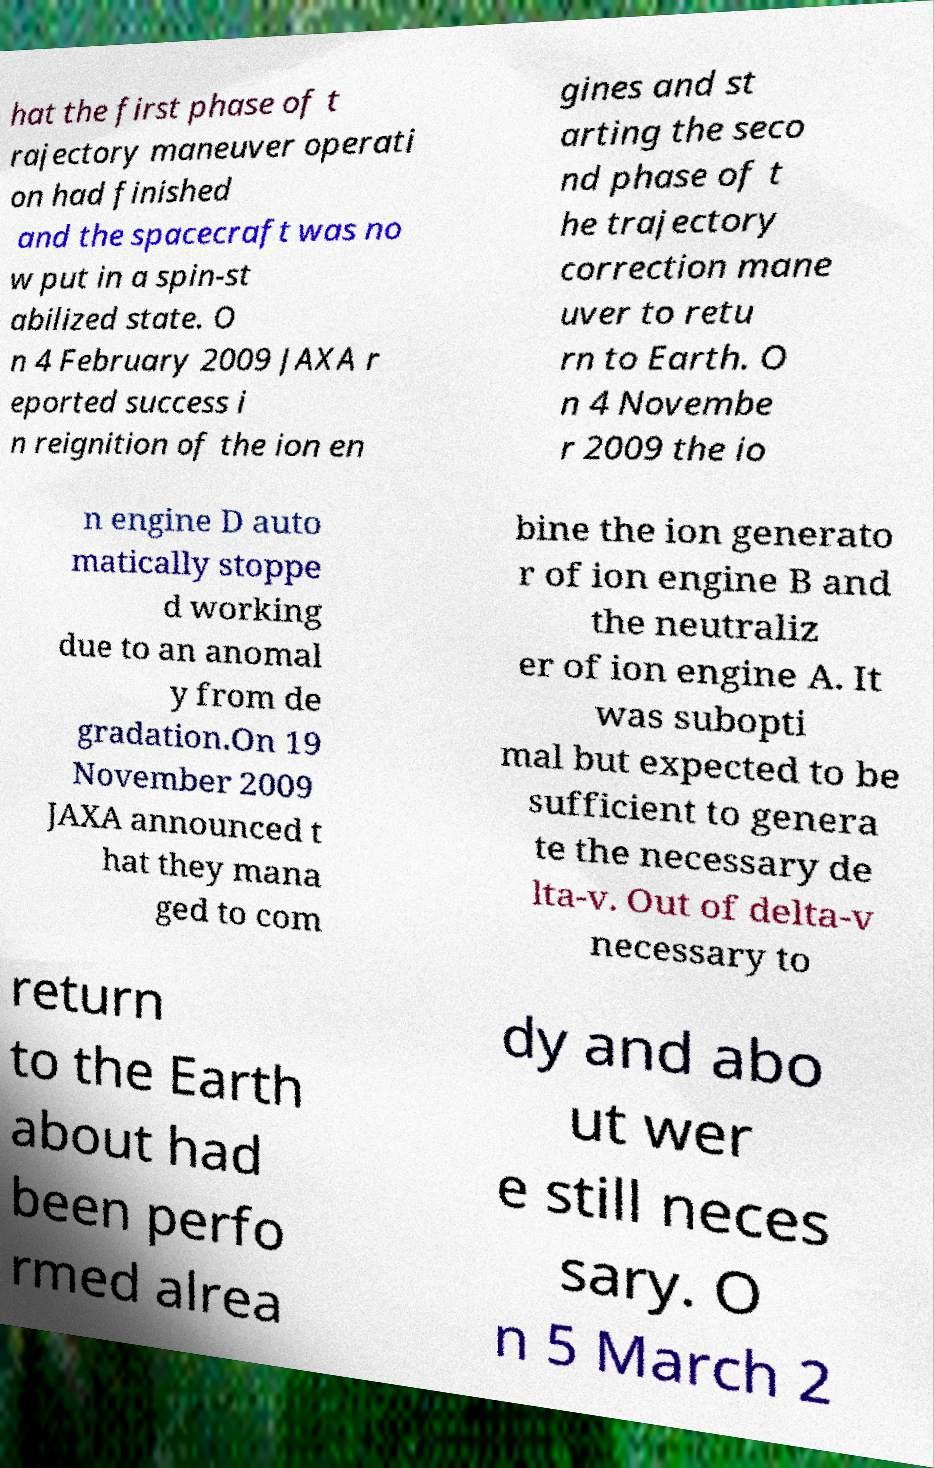There's text embedded in this image that I need extracted. Can you transcribe it verbatim? hat the first phase of t rajectory maneuver operati on had finished and the spacecraft was no w put in a spin-st abilized state. O n 4 February 2009 JAXA r eported success i n reignition of the ion en gines and st arting the seco nd phase of t he trajectory correction mane uver to retu rn to Earth. O n 4 Novembe r 2009 the io n engine D auto matically stoppe d working due to an anomal y from de gradation.On 19 November 2009 JAXA announced t hat they mana ged to com bine the ion generato r of ion engine B and the neutraliz er of ion engine A. It was subopti mal but expected to be sufficient to genera te the necessary de lta-v. Out of delta-v necessary to return to the Earth about had been perfo rmed alrea dy and abo ut wer e still neces sary. O n 5 March 2 